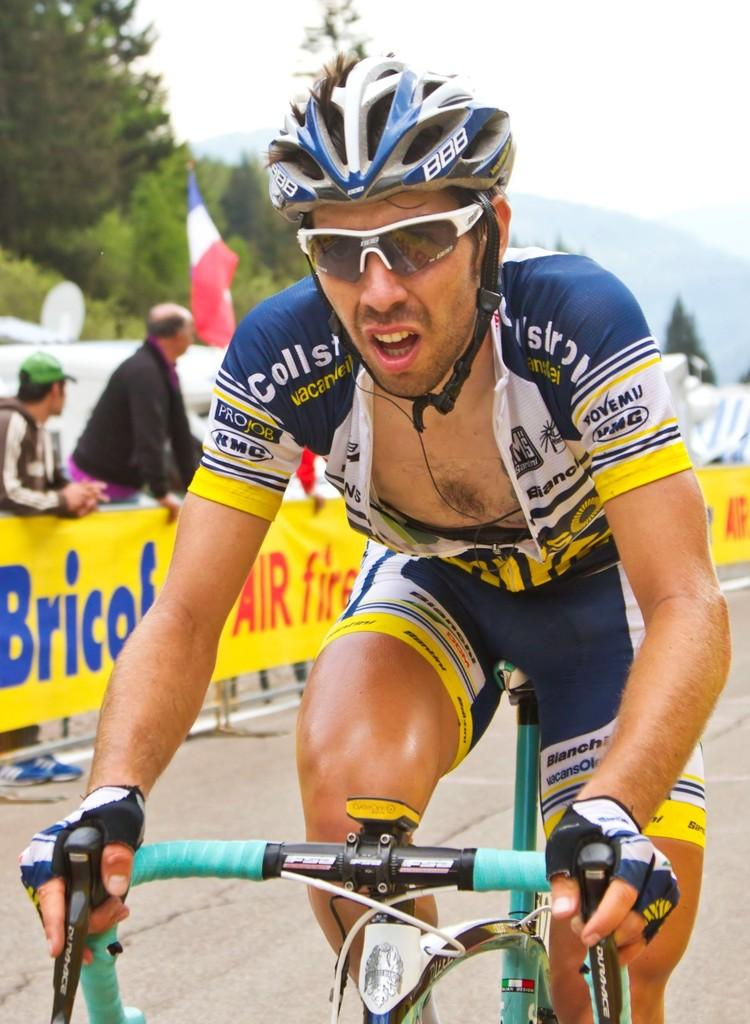What is the person in the image wearing on their head? The person is wearing a helmet in the image. What else is the person wearing in the image? The person is also wearing goggles in the image. What activity is the person engaged in? The person is riding a bicycle in the image. What can be seen in the background of the image? There is a hoarding, a flag, trees, people, and the sky visible in the background of the image. What type of heart-shaped jewelry is the person's aunt wearing in the image? There is no mention of an aunt or any jewelry in the image, so it is not possible to answer that question. 